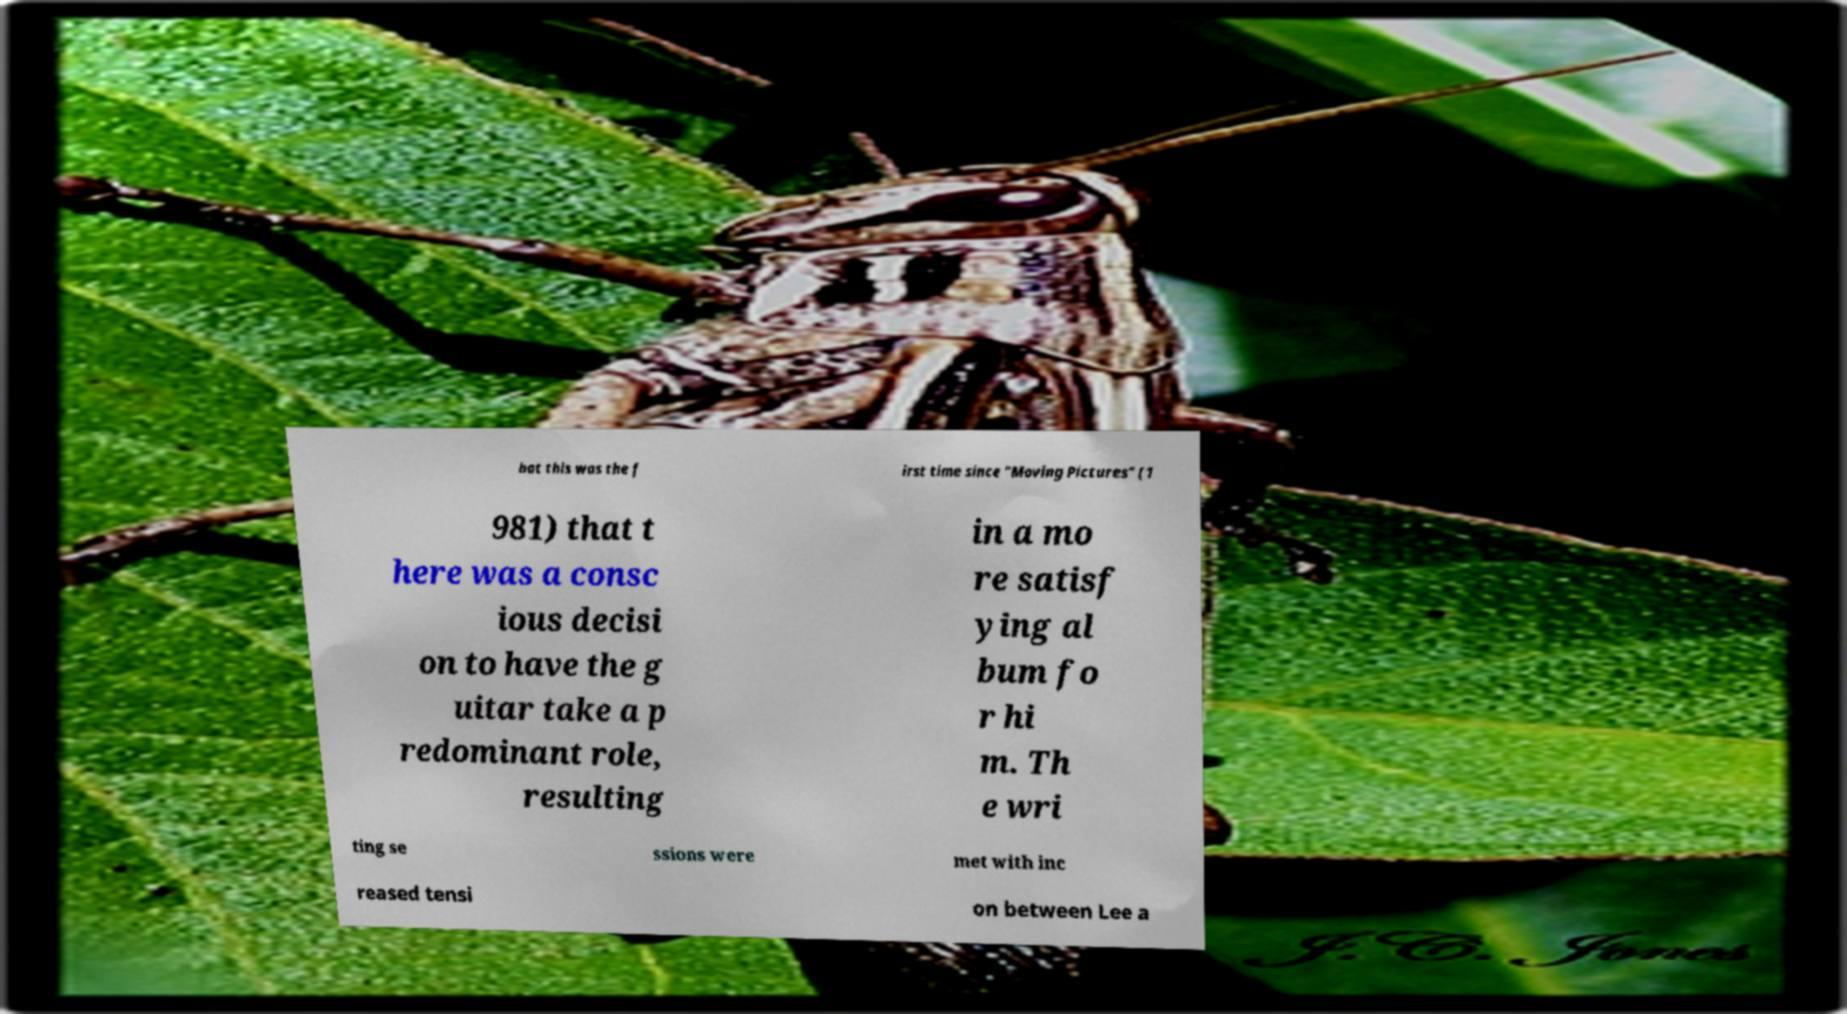Can you accurately transcribe the text from the provided image for me? hat this was the f irst time since "Moving Pictures" (1 981) that t here was a consc ious decisi on to have the g uitar take a p redominant role, resulting in a mo re satisf ying al bum fo r hi m. Th e wri ting se ssions were met with inc reased tensi on between Lee a 